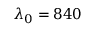<formula> <loc_0><loc_0><loc_500><loc_500>\lambda _ { 0 } = 8 4 0</formula> 